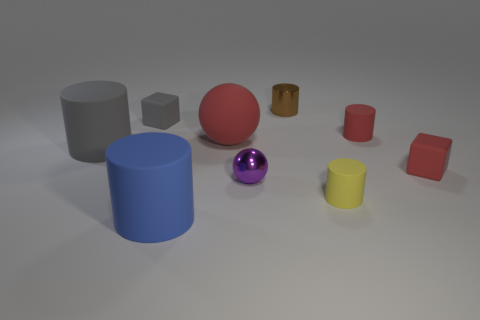What is the size of the purple ball that is in front of the small block that is on the right side of the gray block?
Give a very brief answer. Small. Is the small brown cylinder made of the same material as the sphere that is in front of the large gray rubber thing?
Your response must be concise. Yes. Are there fewer big cylinders on the left side of the small yellow matte thing than red cylinders that are on the left side of the red sphere?
Make the answer very short. No. The large cylinder that is the same material as the blue object is what color?
Your answer should be very brief. Gray. There is a large matte cylinder that is in front of the small metallic sphere; are there any rubber cylinders behind it?
Give a very brief answer. Yes. What color is the rubber cylinder that is the same size as the yellow thing?
Your answer should be very brief. Red. How many things are either matte things or brown blocks?
Ensure brevity in your answer.  7. There is a shiny thing in front of the tiny cube on the left side of the small shiny object that is in front of the small brown cylinder; what size is it?
Make the answer very short. Small. What number of tiny cylinders are the same color as the large ball?
Make the answer very short. 1. What number of green cubes are made of the same material as the tiny yellow object?
Provide a succinct answer. 0. 